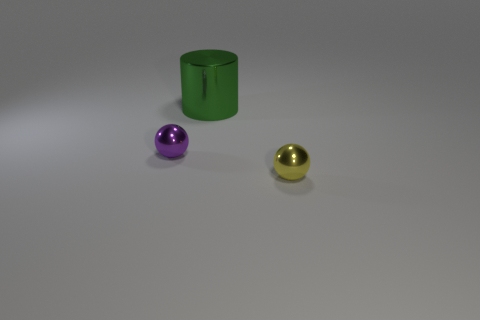Add 3 small things. How many objects exist? 6 Subtract all large green metallic things. Subtract all small yellow balls. How many objects are left? 1 Add 2 green cylinders. How many green cylinders are left? 3 Add 1 large green cylinders. How many large green cylinders exist? 2 Subtract 0 green spheres. How many objects are left? 3 Subtract all cylinders. How many objects are left? 2 